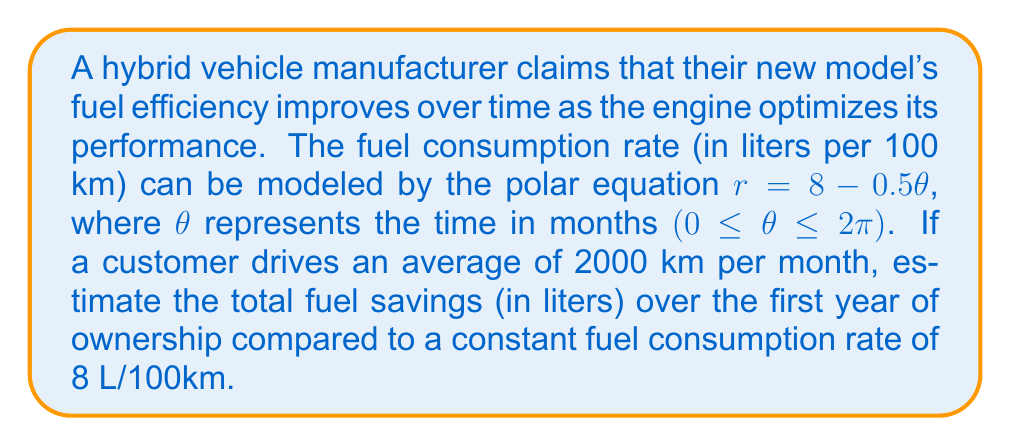What is the answer to this math problem? To solve this problem, we need to follow these steps:

1) First, we need to calculate the area between the spiral curve and the circle with radius 8. This area represents the fuel savings.

2) The area of a sector in polar coordinates is given by the formula:

   $$A = \frac{1}{2} \int_a^b [f(\theta)]^2 d\theta$$

3) In our case, $f(\theta) = 8 - 0.5\theta$, $a = 0$, and $b = 2\pi$ (representing one year).

4) Let's calculate the area:

   $$\begin{align}
   A &= \frac{1}{2} \int_0^{2\pi} (8 - 0.5\theta)^2 d\theta \\
   &= \frac{1}{2} \int_0^{2\pi} (64 - 8\theta + 0.25\theta^2) d\theta \\
   &= \frac{1}{2} [64\theta - 4\theta^2 + \frac{1}{12}\theta^3]_0^{2\pi} \\
   &= \frac{1}{2} [(64(2\pi) - 4(4\pi^2) + \frac{1}{12}(8\pi^3)) - 0] \\
   &= \frac{1}{2} [128\pi - 16\pi^2 + \frac{2}{3}\pi^3] \\
   &≈ 32.99
   \end{align}$$

5) This area represents the fuel savings in L/100km over a year.

6) To convert this to total fuel savings, we need to multiply by the total distance driven:
   
   Total distance = 2000 km/month * 12 months = 24000 km = 240 * 100 km

7) Total fuel savings = 32.99 * 240 = 7917.6 liters
Answer: The estimated total fuel savings over the first year of ownership is approximately 7918 liters. 